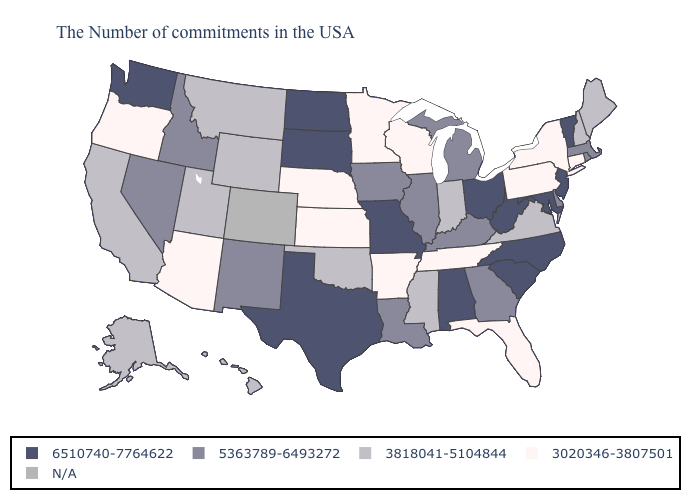Which states have the highest value in the USA?
Write a very short answer. Vermont, New Jersey, Maryland, North Carolina, South Carolina, West Virginia, Ohio, Alabama, Missouri, Texas, South Dakota, North Dakota, Washington. Among the states that border Kentucky , does Ohio have the highest value?
Short answer required. Yes. Name the states that have a value in the range 3818041-5104844?
Concise answer only. Maine, New Hampshire, Virginia, Indiana, Mississippi, Oklahoma, Wyoming, Utah, Montana, California, Alaska, Hawaii. Name the states that have a value in the range 3020346-3807501?
Answer briefly. Connecticut, New York, Pennsylvania, Florida, Tennessee, Wisconsin, Arkansas, Minnesota, Kansas, Nebraska, Arizona, Oregon. Does New Hampshire have the lowest value in the USA?
Quick response, please. No. Name the states that have a value in the range 5363789-6493272?
Write a very short answer. Massachusetts, Rhode Island, Delaware, Georgia, Michigan, Kentucky, Illinois, Louisiana, Iowa, New Mexico, Idaho, Nevada. Is the legend a continuous bar?
Keep it brief. No. What is the lowest value in the USA?
Keep it brief. 3020346-3807501. Does Kansas have the lowest value in the USA?
Concise answer only. Yes. What is the value of West Virginia?
Be succinct. 6510740-7764622. How many symbols are there in the legend?
Be succinct. 5. What is the value of Washington?
Keep it brief. 6510740-7764622. What is the highest value in states that border Alabama?
Concise answer only. 5363789-6493272. Does the first symbol in the legend represent the smallest category?
Be succinct. No. 